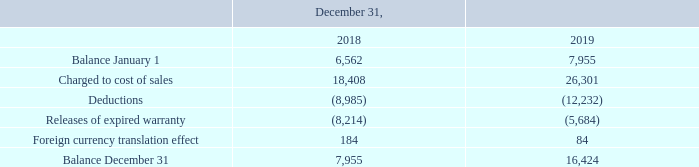NOTE 14. PROVISION FOR WARRANTY
The changes in the amount of provision for warranty are as follows:
Costs of warranty include the cost of labor and materials to repair a product during the warranty period. The main term of the warranty period is one year. The Company accrues for the estimated cost of the warranty on its products shipped in the provision for warranty, upon recognition of the sale of the product. The costs are estimated based on actual historical expenses incurred and on estimated future expenses related to current sales, and are updated periodically. Actual warranty costs are charged against the provision for warranty.
What does cost of warranty include? The cost of labor and materials to repair a product during the warranty period. How are warranty costs estimated? Based on actual historical expenses incurred and on estimated future expenses related to current sales, and are updated periodically. For what years are the costs of warranty information provided? 2018, 2019. Which year had a larger difference in the balance between the start and the end of the year? 2018:(7,955-6,562=1,393); 2019:(16,424-7,955=8,469)
Answer: 2019. What is the percentage change in balance at end of year from 2018 to 2019?
Answer scale should be: percent. (16,424-7,955)/7,955
Answer: 106.46. What is the change in balance at start of year from 2018 to 2019?  7,955 - 6,562 
Answer: 1393. 